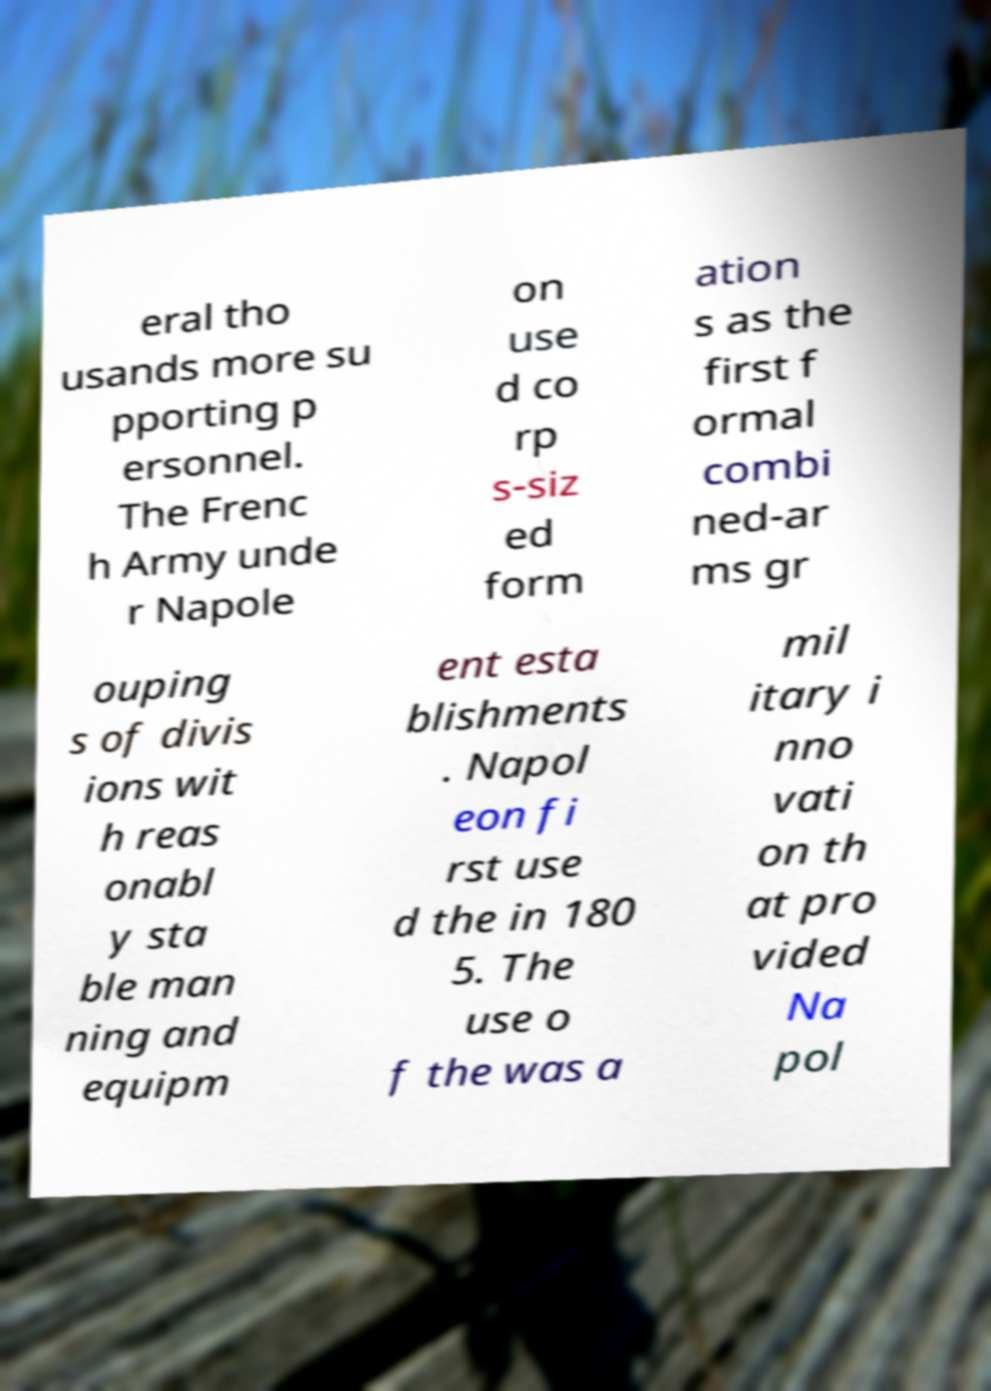Could you extract and type out the text from this image? eral tho usands more su pporting p ersonnel. The Frenc h Army unde r Napole on use d co rp s-siz ed form ation s as the first f ormal combi ned-ar ms gr ouping s of divis ions wit h reas onabl y sta ble man ning and equipm ent esta blishments . Napol eon fi rst use d the in 180 5. The use o f the was a mil itary i nno vati on th at pro vided Na pol 